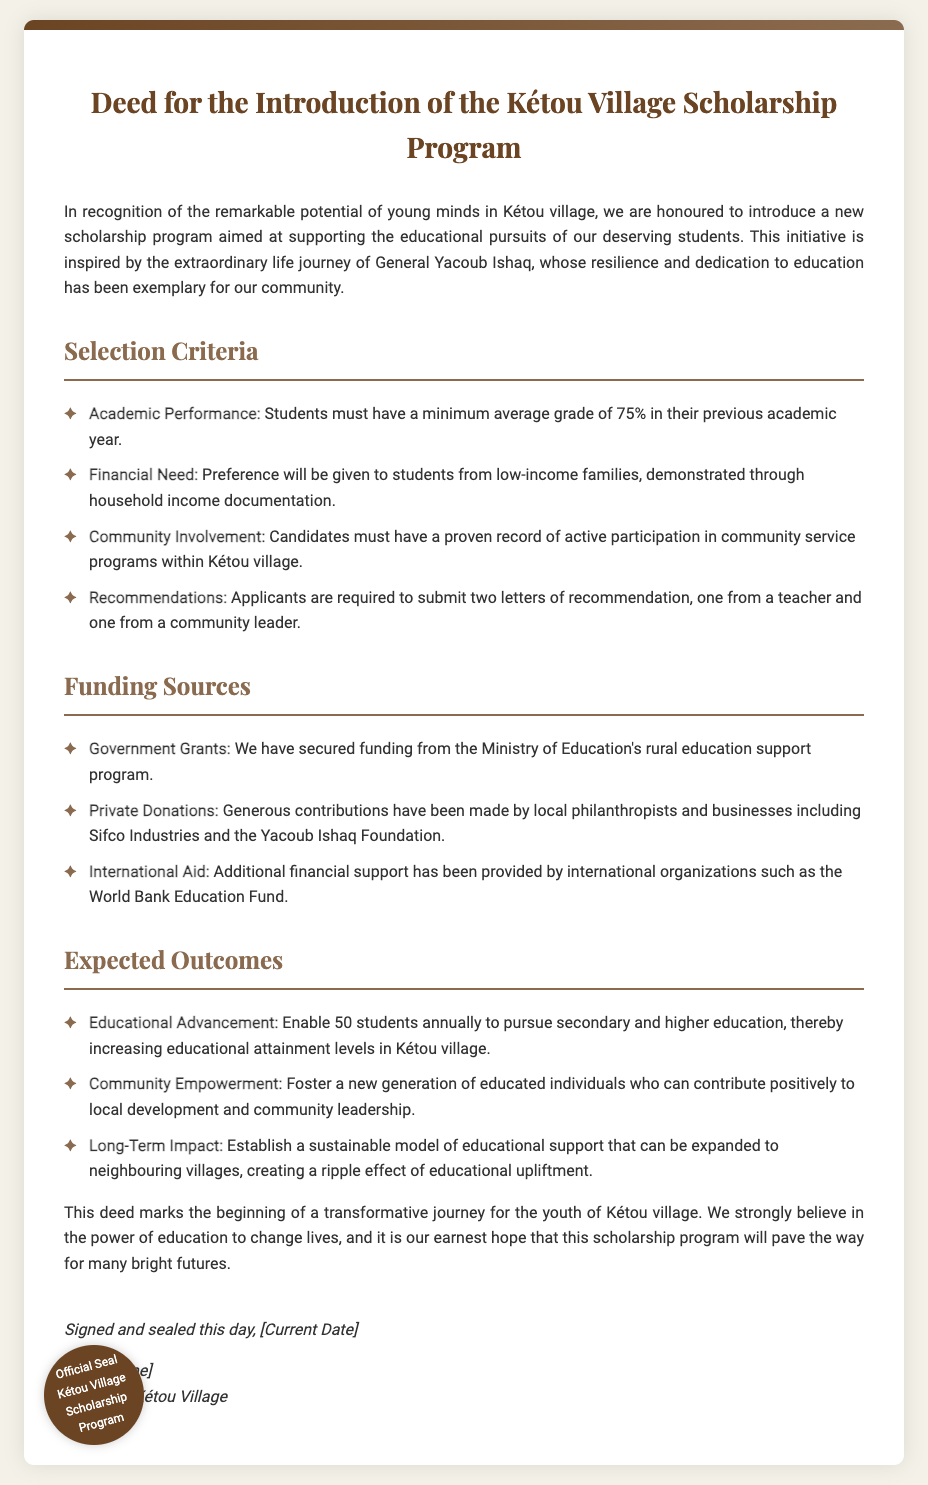What is the minimum average grade required? The document states the minimum average grade must be 75% in the previous academic year.
Answer: 75% Who is the scholarship program inspired by? The document mentions the program is inspired by General Yacoub Ishaq's extraordinary life journey.
Answer: General Yacoub Ishaq How many students will be enabled annually for education? The expected outcome indicates that the program will enable 50 students annually.
Answer: 50 What type of letters are required for recommendations? The document requires two letters, one from a teacher and one from a community leader.
Answer: One from a teacher and one from a community leader Which organization provided additional financial support? The text states that international organizations such as the World Bank Education Fund provided additional support.
Answer: World Bank Education Fund What is one specific outcome of the scholarship program? The document outlines that one expected outcome is to enable educational advancement.
Answer: Educational Advancement From which program has funding been secured? The document specifies that funding has been secured from the Ministry of Education's rural education support program.
Answer: Ministry of Education's rural education support program What degree of community service involvement is required for candidates? Candidates must have a proven record of active participation in community service programs within Kétou village.
Answer: Active participation What is the date on which the deed is signed? The document includes a placeholder for the date, indicating it should reflect the current date.
Answer: [Current Date] 